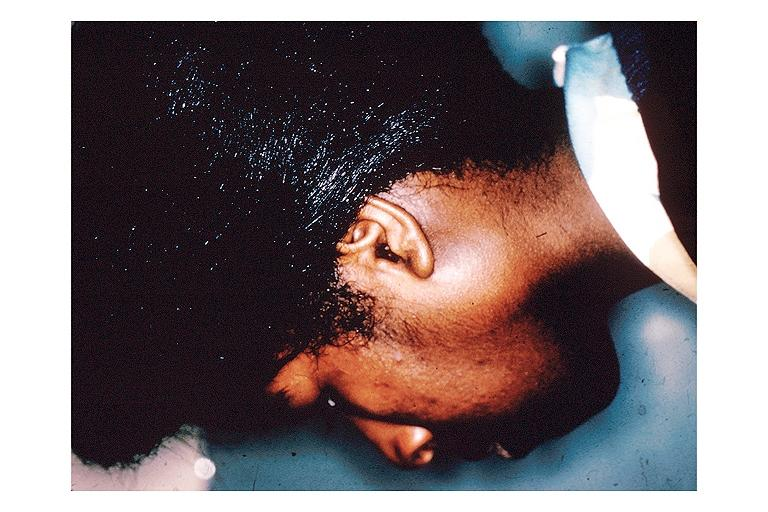what does this image show?
Answer the question using a single word or phrase. Sarcoidosis 